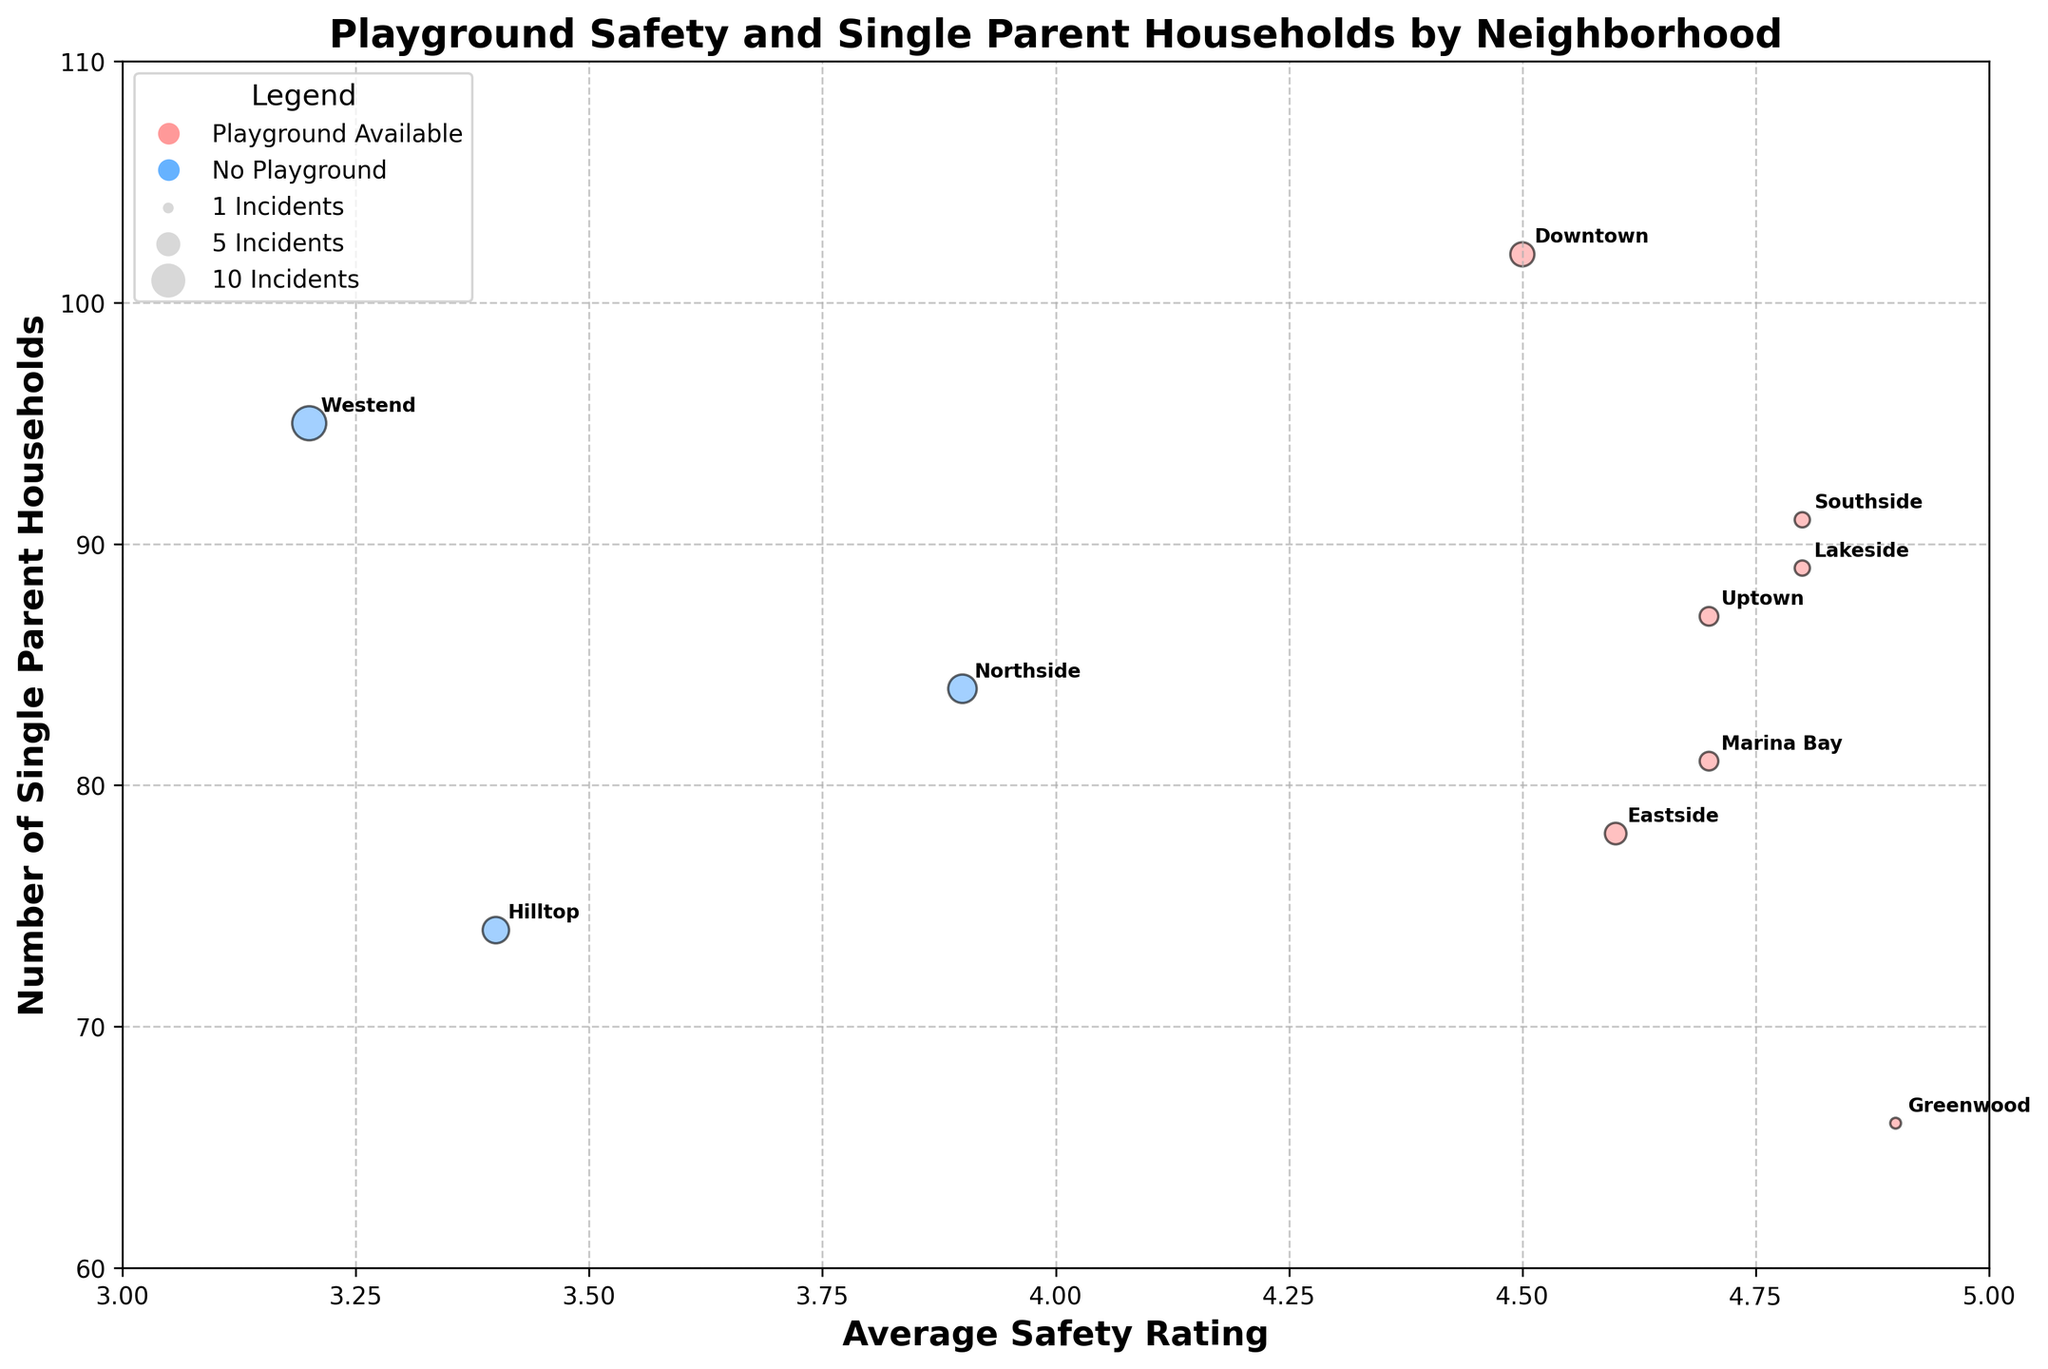what is the title of the chart? The title of the chart can be found at the top of the figure. It is usually a descriptive text that summarizes the main topic or focus of the chart.
Answer: Playground Safety and Single Parent Households by Neighborhood How many neighborhoods have playgrounds available? To answer this, count the number of bubbles colored in a specific way to denote playground availability.
Answer: 7 Which neighborhood has the highest average safety rating and playground availability? Identify the highest point on the x-axis (Average Safety Rating) and check if it belongs to a playground-available neighborhood.
Answer: Greenwood Which neighborhood reported the most incidents and also does not have a playground? Observe the largest bubble size and ensure it corresponds to a neighborhood without a playground (e.g., color-coded "No Playground").
Answer: Westend What is the safety rating and number of single-parent households for Westend? Locate the Westend bubble and note its x-axis (Average Safety Rating) and y-axis (Number of Single Parent Households) positions.
Answer: 3.2 and 95 Compare the total number of single-parent households in neighborhoods with and without playgrounds. Which is higher? Add the y-values (Number of Single Parent Households) for bubbles of corresponding colors to find the totals for "Yes" and "No" playground availability.
Answer: Playgrounds: 594, No Playgrounds: 253 How many neighborhoods have a safety rating of at least 4.0? Count the bubbles positioned at or to the right of the 4.0 mark on the x-axis.
Answer: 7 Which neighborhoods have more than 90 single-parent households and playgrounds available? Identify bubbles with y-values above 90 and the color representing playground availability.
Answer: Downtown and Southside If the incidents reported are doubled, how would the bubble sizes change for Southside and Northside? Calculate new sizes by multiplying their incident counts by 40 (double current bubble size as current size represents 20 times the incident count).
Answer: Southside: 80, Northside: 140 Among the neighborhoods with the highest and lowest safety ratings, compare the number of single-parent households. Locate the bubbles on extreme ends of the x-axis and compare their y-values.
Answer: Highest (Greenwood): 66, Lowest (Westend): 95 